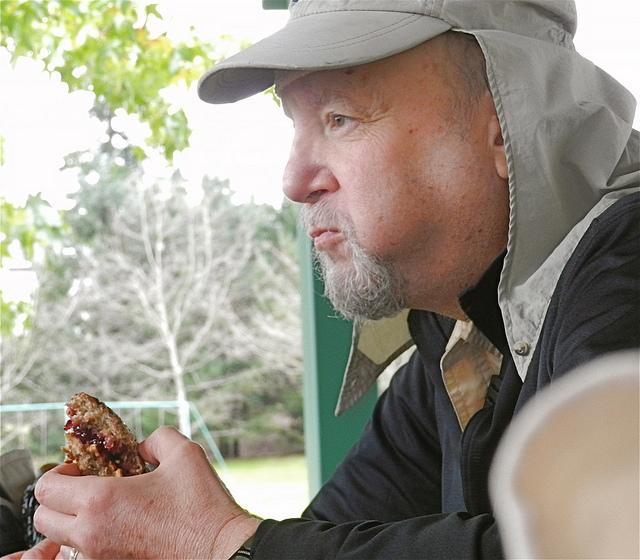What type of sandwich is the man holding?
Short answer required. Peanut butter and jelly. What is the man wearing?
Concise answer only. Hat. Is this man's head tilted to one side?
Keep it brief. No. What is the man eating?
Keep it brief. Sandwich. This man is eating alone?
Write a very short answer. Yes. What color is the man's hat?
Concise answer only. Gray. 